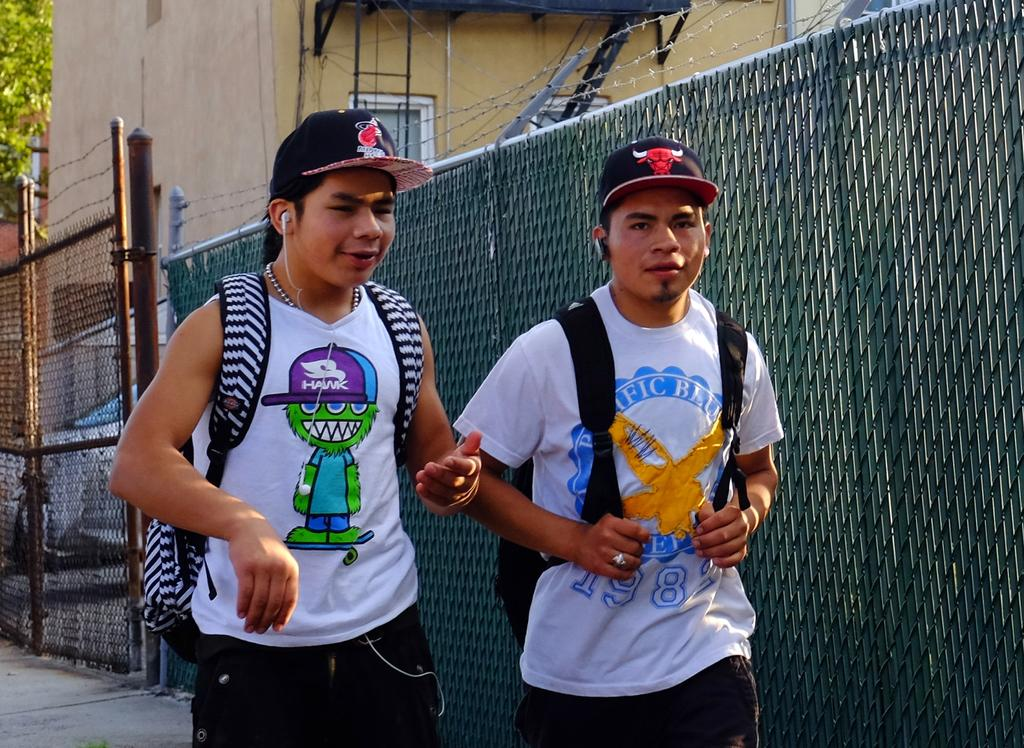Provide a one-sentence caption for the provided image. two boys walking, one with Pacific Blue on his white tee shirt. 